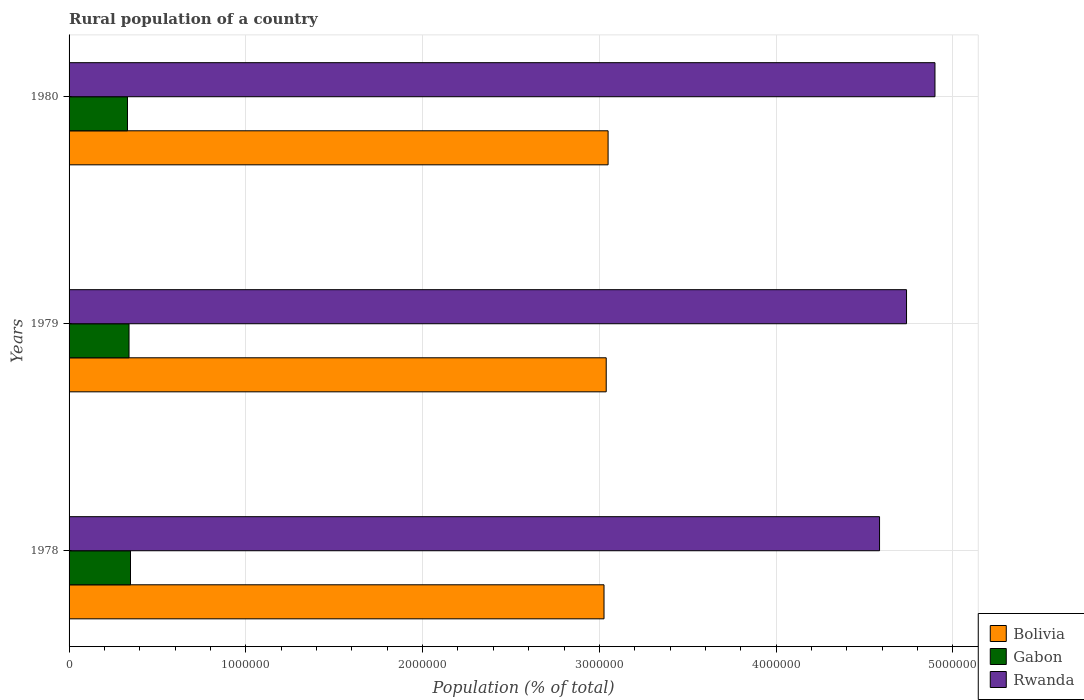How many different coloured bars are there?
Provide a short and direct response. 3. How many groups of bars are there?
Make the answer very short. 3. Are the number of bars per tick equal to the number of legend labels?
Your answer should be compact. Yes. What is the label of the 2nd group of bars from the top?
Provide a succinct answer. 1979. In how many cases, is the number of bars for a given year not equal to the number of legend labels?
Ensure brevity in your answer.  0. What is the rural population in Gabon in 1980?
Offer a terse response. 3.30e+05. Across all years, what is the maximum rural population in Rwanda?
Offer a terse response. 4.90e+06. Across all years, what is the minimum rural population in Bolivia?
Ensure brevity in your answer.  3.03e+06. In which year was the rural population in Bolivia minimum?
Your response must be concise. 1978. What is the total rural population in Bolivia in the graph?
Give a very brief answer. 9.11e+06. What is the difference between the rural population in Bolivia in 1978 and that in 1980?
Your response must be concise. -2.30e+04. What is the difference between the rural population in Gabon in 1979 and the rural population in Bolivia in 1980?
Provide a succinct answer. -2.71e+06. What is the average rural population in Rwanda per year?
Give a very brief answer. 4.74e+06. In the year 1980, what is the difference between the rural population in Bolivia and rural population in Rwanda?
Give a very brief answer. -1.85e+06. In how many years, is the rural population in Rwanda greater than 2800000 %?
Your answer should be compact. 3. What is the ratio of the rural population in Gabon in 1978 to that in 1979?
Make the answer very short. 1.02. What is the difference between the highest and the second highest rural population in Bolivia?
Your response must be concise. 1.06e+04. What is the difference between the highest and the lowest rural population in Rwanda?
Keep it short and to the point. 3.14e+05. Is the sum of the rural population in Gabon in 1978 and 1980 greater than the maximum rural population in Bolivia across all years?
Your answer should be compact. No. What does the 2nd bar from the top in 1978 represents?
Your answer should be very brief. Gabon. What does the 1st bar from the bottom in 1978 represents?
Offer a very short reply. Bolivia. What is the difference between two consecutive major ticks on the X-axis?
Provide a succinct answer. 1.00e+06. Are the values on the major ticks of X-axis written in scientific E-notation?
Ensure brevity in your answer.  No. Does the graph contain any zero values?
Offer a very short reply. No. How many legend labels are there?
Your response must be concise. 3. How are the legend labels stacked?
Ensure brevity in your answer.  Vertical. What is the title of the graph?
Offer a very short reply. Rural population of a country. Does "Bosnia and Herzegovina" appear as one of the legend labels in the graph?
Your answer should be compact. No. What is the label or title of the X-axis?
Make the answer very short. Population (% of total). What is the label or title of the Y-axis?
Provide a short and direct response. Years. What is the Population (% of total) in Bolivia in 1978?
Keep it short and to the point. 3.03e+06. What is the Population (% of total) in Gabon in 1978?
Your answer should be compact. 3.47e+05. What is the Population (% of total) of Rwanda in 1978?
Your answer should be very brief. 4.58e+06. What is the Population (% of total) of Bolivia in 1979?
Provide a short and direct response. 3.04e+06. What is the Population (% of total) in Gabon in 1979?
Provide a succinct answer. 3.39e+05. What is the Population (% of total) in Rwanda in 1979?
Offer a terse response. 4.74e+06. What is the Population (% of total) in Bolivia in 1980?
Provide a short and direct response. 3.05e+06. What is the Population (% of total) in Gabon in 1980?
Provide a succinct answer. 3.30e+05. What is the Population (% of total) of Rwanda in 1980?
Your answer should be very brief. 4.90e+06. Across all years, what is the maximum Population (% of total) of Bolivia?
Offer a terse response. 3.05e+06. Across all years, what is the maximum Population (% of total) in Gabon?
Give a very brief answer. 3.47e+05. Across all years, what is the maximum Population (% of total) of Rwanda?
Your response must be concise. 4.90e+06. Across all years, what is the minimum Population (% of total) of Bolivia?
Your response must be concise. 3.03e+06. Across all years, what is the minimum Population (% of total) of Gabon?
Provide a short and direct response. 3.30e+05. Across all years, what is the minimum Population (% of total) of Rwanda?
Offer a very short reply. 4.58e+06. What is the total Population (% of total) in Bolivia in the graph?
Give a very brief answer. 9.11e+06. What is the total Population (% of total) in Gabon in the graph?
Provide a short and direct response. 1.02e+06. What is the total Population (% of total) of Rwanda in the graph?
Offer a very short reply. 1.42e+07. What is the difference between the Population (% of total) of Bolivia in 1978 and that in 1979?
Make the answer very short. -1.24e+04. What is the difference between the Population (% of total) of Gabon in 1978 and that in 1979?
Your answer should be compact. 8328. What is the difference between the Population (% of total) in Rwanda in 1978 and that in 1979?
Offer a terse response. -1.53e+05. What is the difference between the Population (% of total) in Bolivia in 1978 and that in 1980?
Provide a succinct answer. -2.30e+04. What is the difference between the Population (% of total) of Gabon in 1978 and that in 1980?
Your answer should be very brief. 1.70e+04. What is the difference between the Population (% of total) of Rwanda in 1978 and that in 1980?
Offer a terse response. -3.14e+05. What is the difference between the Population (% of total) of Bolivia in 1979 and that in 1980?
Make the answer very short. -1.06e+04. What is the difference between the Population (% of total) of Gabon in 1979 and that in 1980?
Your answer should be very brief. 8700. What is the difference between the Population (% of total) in Rwanda in 1979 and that in 1980?
Your response must be concise. -1.61e+05. What is the difference between the Population (% of total) in Bolivia in 1978 and the Population (% of total) in Gabon in 1979?
Provide a short and direct response. 2.69e+06. What is the difference between the Population (% of total) in Bolivia in 1978 and the Population (% of total) in Rwanda in 1979?
Make the answer very short. -1.71e+06. What is the difference between the Population (% of total) of Gabon in 1978 and the Population (% of total) of Rwanda in 1979?
Offer a very short reply. -4.39e+06. What is the difference between the Population (% of total) in Bolivia in 1978 and the Population (% of total) in Gabon in 1980?
Provide a succinct answer. 2.70e+06. What is the difference between the Population (% of total) of Bolivia in 1978 and the Population (% of total) of Rwanda in 1980?
Your response must be concise. -1.87e+06. What is the difference between the Population (% of total) in Gabon in 1978 and the Population (% of total) in Rwanda in 1980?
Ensure brevity in your answer.  -4.55e+06. What is the difference between the Population (% of total) of Bolivia in 1979 and the Population (% of total) of Gabon in 1980?
Keep it short and to the point. 2.71e+06. What is the difference between the Population (% of total) of Bolivia in 1979 and the Population (% of total) of Rwanda in 1980?
Offer a very short reply. -1.86e+06. What is the difference between the Population (% of total) of Gabon in 1979 and the Population (% of total) of Rwanda in 1980?
Offer a terse response. -4.56e+06. What is the average Population (% of total) of Bolivia per year?
Provide a short and direct response. 3.04e+06. What is the average Population (% of total) in Gabon per year?
Offer a very short reply. 3.39e+05. What is the average Population (% of total) in Rwanda per year?
Ensure brevity in your answer.  4.74e+06. In the year 1978, what is the difference between the Population (% of total) in Bolivia and Population (% of total) in Gabon?
Your answer should be compact. 2.68e+06. In the year 1978, what is the difference between the Population (% of total) in Bolivia and Population (% of total) in Rwanda?
Make the answer very short. -1.56e+06. In the year 1978, what is the difference between the Population (% of total) of Gabon and Population (% of total) of Rwanda?
Ensure brevity in your answer.  -4.24e+06. In the year 1979, what is the difference between the Population (% of total) in Bolivia and Population (% of total) in Gabon?
Make the answer very short. 2.70e+06. In the year 1979, what is the difference between the Population (% of total) of Bolivia and Population (% of total) of Rwanda?
Keep it short and to the point. -1.70e+06. In the year 1979, what is the difference between the Population (% of total) of Gabon and Population (% of total) of Rwanda?
Your response must be concise. -4.40e+06. In the year 1980, what is the difference between the Population (% of total) of Bolivia and Population (% of total) of Gabon?
Provide a succinct answer. 2.72e+06. In the year 1980, what is the difference between the Population (% of total) of Bolivia and Population (% of total) of Rwanda?
Make the answer very short. -1.85e+06. In the year 1980, what is the difference between the Population (% of total) of Gabon and Population (% of total) of Rwanda?
Your answer should be very brief. -4.57e+06. What is the ratio of the Population (% of total) in Bolivia in 1978 to that in 1979?
Give a very brief answer. 1. What is the ratio of the Population (% of total) in Gabon in 1978 to that in 1979?
Provide a short and direct response. 1.02. What is the ratio of the Population (% of total) of Rwanda in 1978 to that in 1979?
Offer a very short reply. 0.97. What is the ratio of the Population (% of total) in Bolivia in 1978 to that in 1980?
Your response must be concise. 0.99. What is the ratio of the Population (% of total) in Gabon in 1978 to that in 1980?
Give a very brief answer. 1.05. What is the ratio of the Population (% of total) of Rwanda in 1978 to that in 1980?
Your answer should be compact. 0.94. What is the ratio of the Population (% of total) of Gabon in 1979 to that in 1980?
Give a very brief answer. 1.03. What is the ratio of the Population (% of total) in Rwanda in 1979 to that in 1980?
Offer a very short reply. 0.97. What is the difference between the highest and the second highest Population (% of total) in Bolivia?
Provide a succinct answer. 1.06e+04. What is the difference between the highest and the second highest Population (% of total) of Gabon?
Provide a succinct answer. 8328. What is the difference between the highest and the second highest Population (% of total) of Rwanda?
Give a very brief answer. 1.61e+05. What is the difference between the highest and the lowest Population (% of total) in Bolivia?
Your answer should be compact. 2.30e+04. What is the difference between the highest and the lowest Population (% of total) of Gabon?
Offer a very short reply. 1.70e+04. What is the difference between the highest and the lowest Population (% of total) of Rwanda?
Offer a terse response. 3.14e+05. 